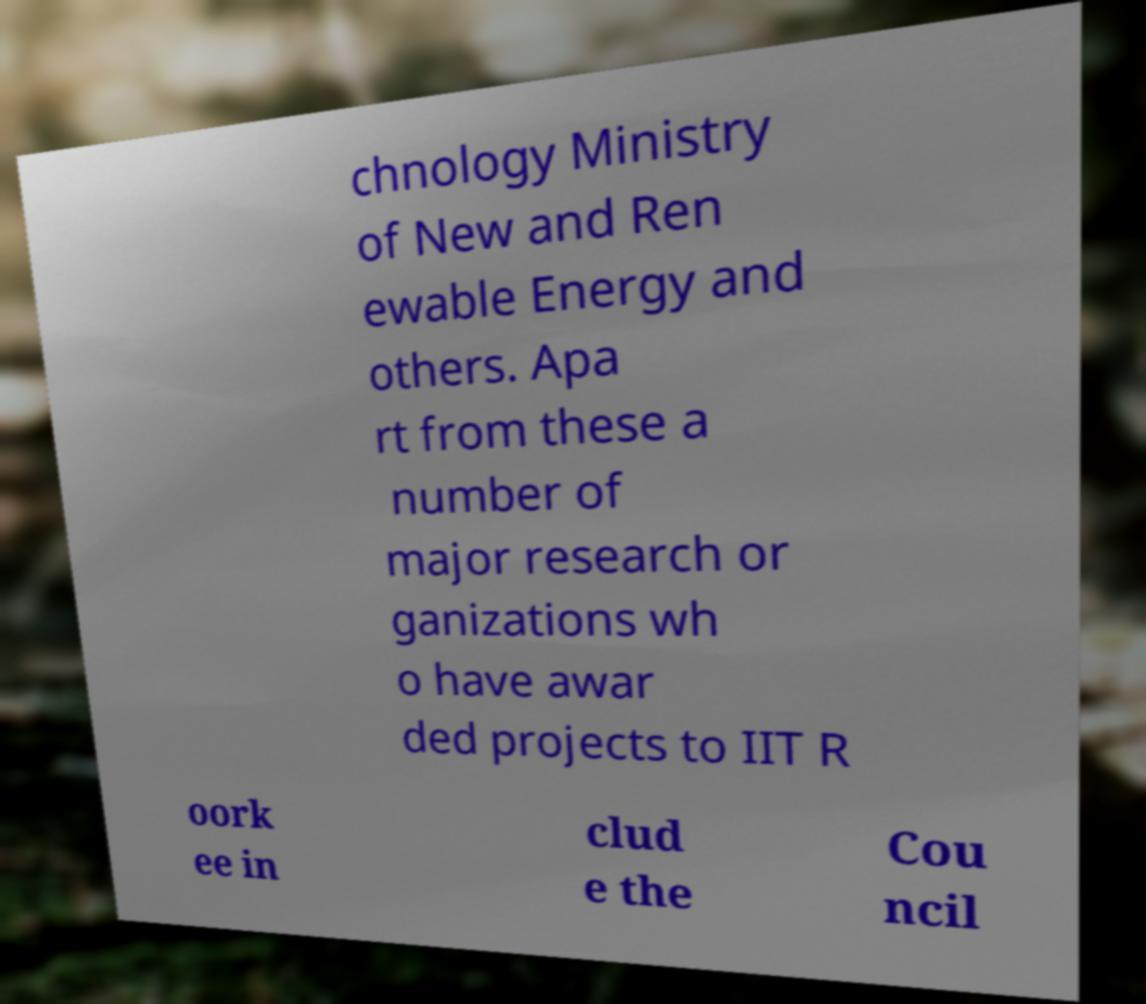Please read and relay the text visible in this image. What does it say? chnology Ministry of New and Ren ewable Energy and others. Apa rt from these a number of major research or ganizations wh o have awar ded projects to IIT R oork ee in clud e the Cou ncil 